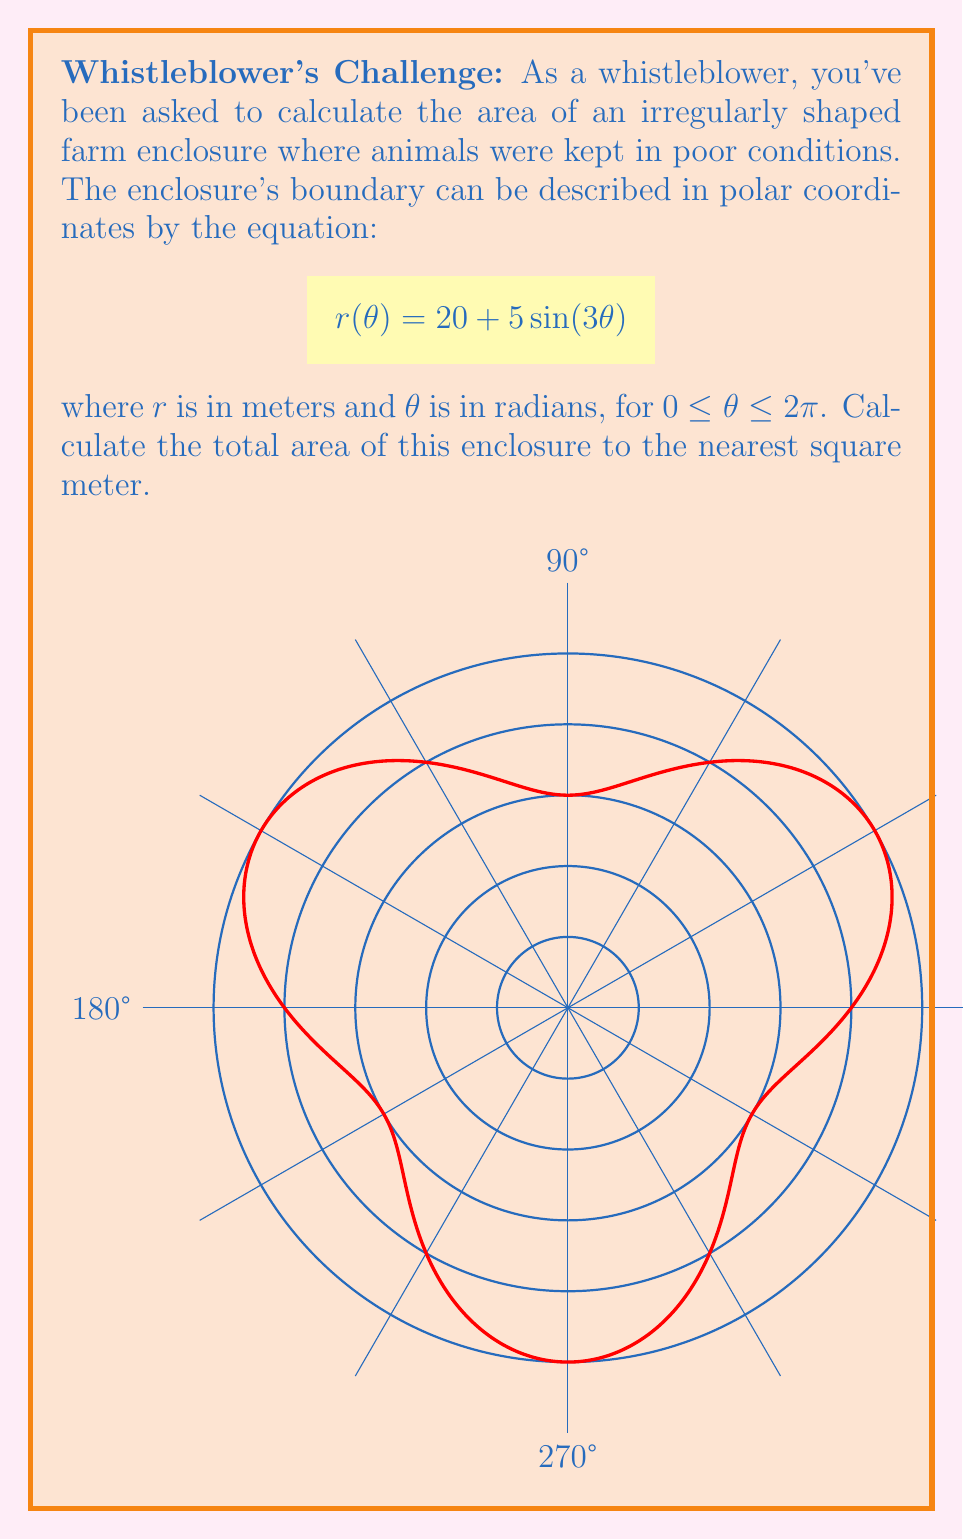Can you answer this question? To calculate the area of this irregularly shaped enclosure using polar coordinates, we'll use the formula:

$$A = \frac{1}{2} \int_{0}^{2\pi} [r(\theta)]^2 d\theta$$

Step 1: Substitute the given function into the area formula:
$$A = \frac{1}{2} \int_{0}^{2\pi} [20 + 5\sin(3\theta)]^2 d\theta$$

Step 2: Expand the squared term:
$$A = \frac{1}{2} \int_{0}^{2\pi} [400 + 200\sin(3\theta) + 25\sin^2(3\theta)] d\theta$$

Step 3: Integrate each term:
- $\int_{0}^{2\pi} 400 d\theta = 400 \cdot 2\pi = 800\pi$
- $\int_{0}^{2\pi} 200\sin(3\theta) d\theta = 0$ (since it's a full period)
- $\int_{0}^{2\pi} 25\sin^2(3\theta) d\theta = 25 \cdot \frac{\pi}{2} = \frac{25\pi}{2}$ (using $\int_{0}^{2\pi} \sin^2(x) dx = \pi$)

Step 4: Sum up the results:
$$A = \frac{1}{2} \left(800\pi + 0 + \frac{25\pi}{2}\right) = 400\pi + \frac{25\pi}{4} = \frac{1625\pi}{4}$$

Step 5: Calculate the numerical value:
$$A = \frac{1625\pi}{4} \approx 1273.24 \text{ m}^2$$

Step 6: Round to the nearest square meter:
$$A \approx 1273 \text{ m}^2$$
Answer: 1273 m² 